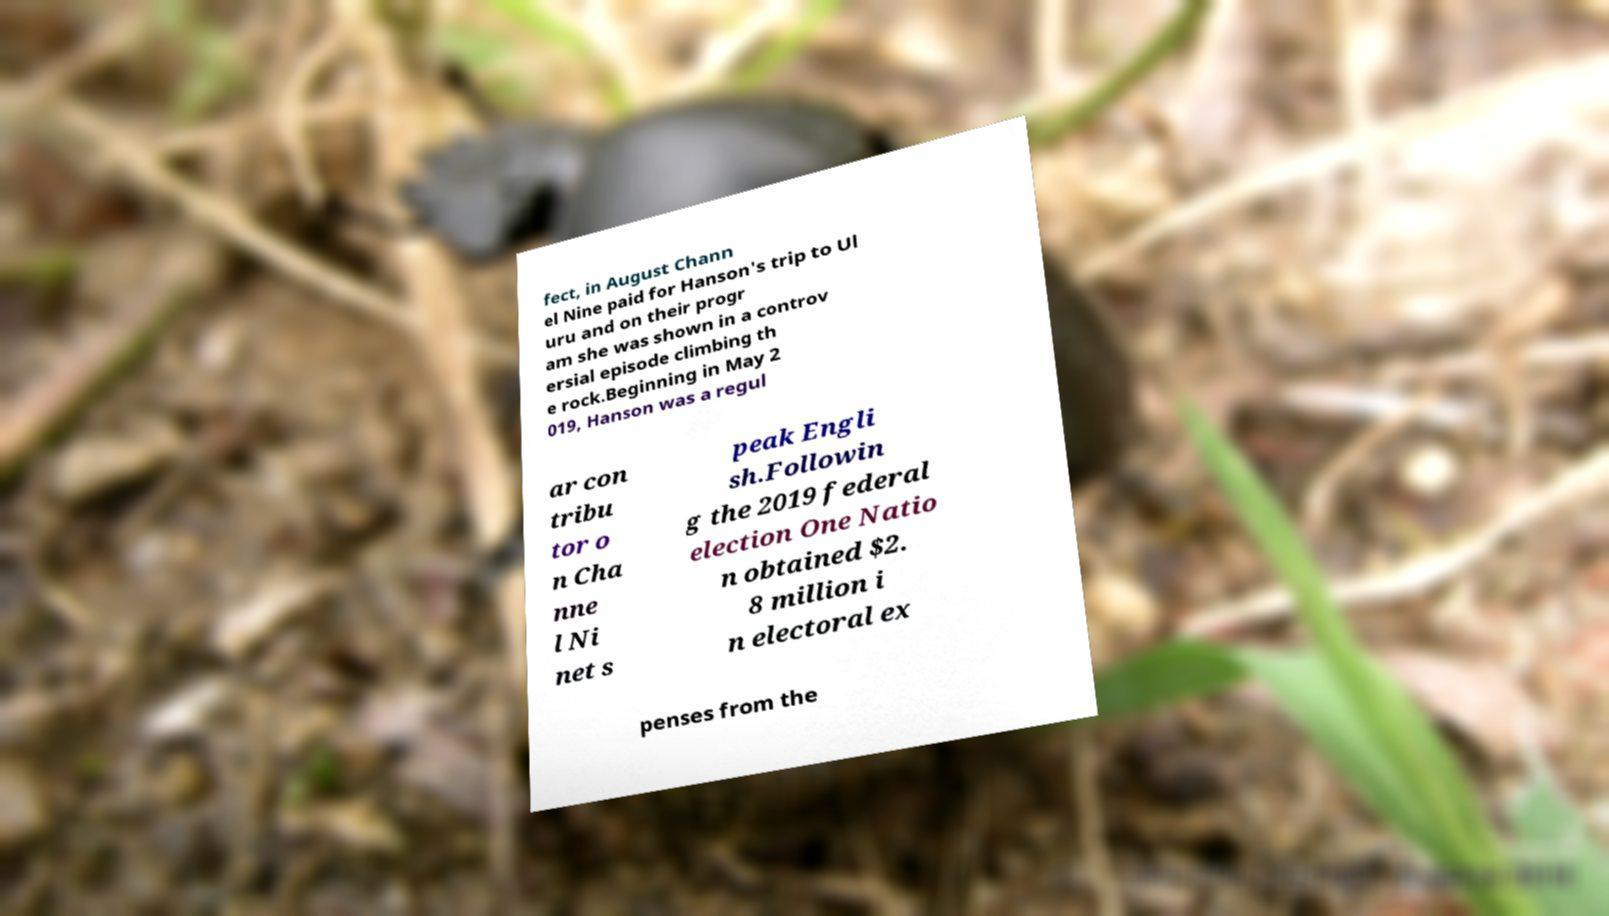Can you read and provide the text displayed in the image?This photo seems to have some interesting text. Can you extract and type it out for me? fect, in August Chann el Nine paid for Hanson's trip to Ul uru and on their progr am she was shown in a controv ersial episode climbing th e rock.Beginning in May 2 019, Hanson was a regul ar con tribu tor o n Cha nne l Ni net s peak Engli sh.Followin g the 2019 federal election One Natio n obtained $2. 8 million i n electoral ex penses from the 